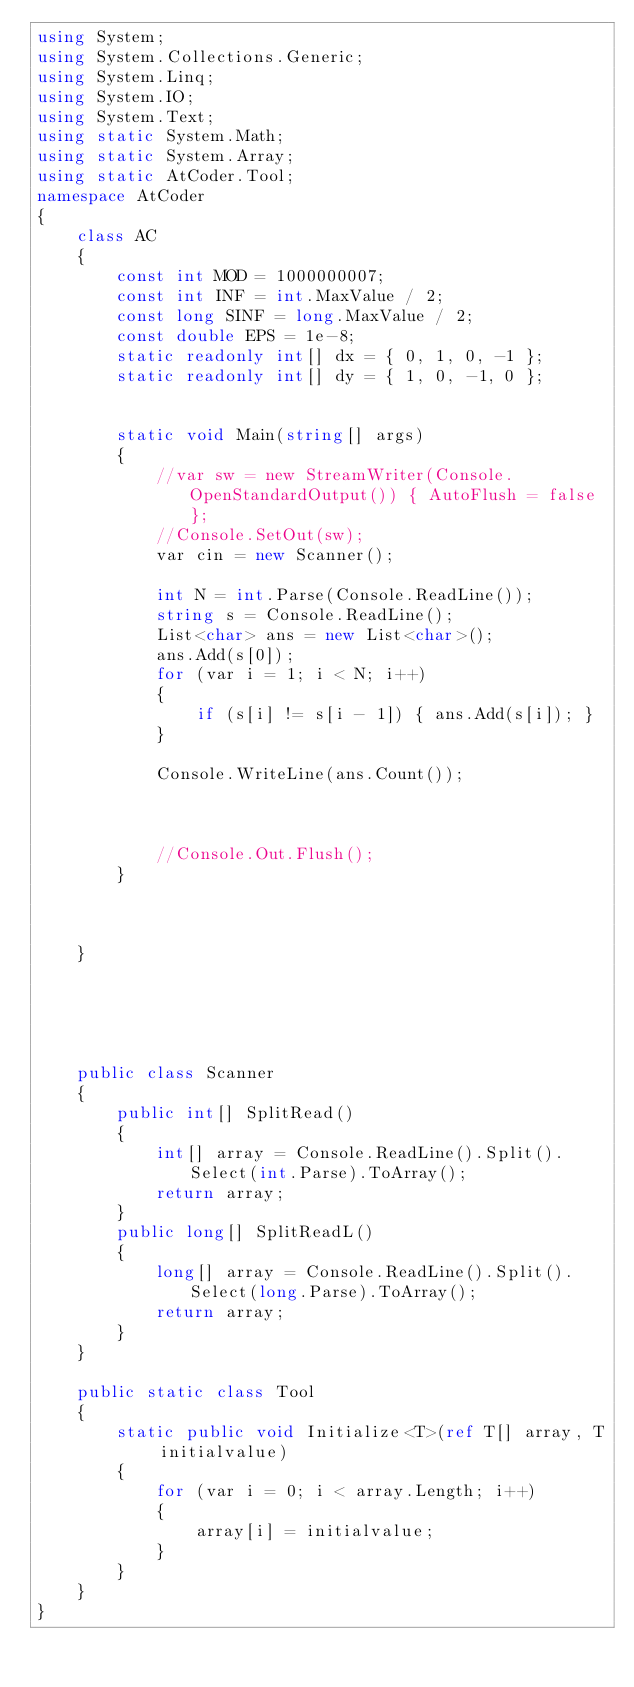Convert code to text. <code><loc_0><loc_0><loc_500><loc_500><_C#_>using System;
using System.Collections.Generic;
using System.Linq;
using System.IO;
using System.Text;
using static System.Math;
using static System.Array;
using static AtCoder.Tool;
namespace AtCoder
{
    class AC
    {
        const int MOD = 1000000007;
        const int INF = int.MaxValue / 2;
        const long SINF = long.MaxValue / 2;
        const double EPS = 1e-8;
        static readonly int[] dx = { 0, 1, 0, -1 };
        static readonly int[] dy = { 1, 0, -1, 0 };
       

        static void Main(string[] args)
        {
            //var sw = new StreamWriter(Console.OpenStandardOutput()) { AutoFlush = false };
            //Console.SetOut(sw);
            var cin = new Scanner();

            int N = int.Parse(Console.ReadLine());
            string s = Console.ReadLine();
            List<char> ans = new List<char>();
            ans.Add(s[0]);
            for (var i = 1; i < N; i++)
            {
                if (s[i] != s[i - 1]) { ans.Add(s[i]); }
            }

            Console.WriteLine(ans.Count());

            

            //Console.Out.Flush();
        }
        


    }

    

    

    public class Scanner
    {
        public int[] SplitRead()
        {
            int[] array = Console.ReadLine().Split().Select(int.Parse).ToArray();
            return array;
        }
        public long[] SplitReadL()
        {
            long[] array = Console.ReadLine().Split().Select(long.Parse).ToArray();
            return array;
        }
    }

    public static class Tool
    {
        static public void Initialize<T>(ref T[] array, T initialvalue)
        {
            for (var i = 0; i < array.Length; i++)
            {
                array[i] = initialvalue;
            }
        }
    }
}
</code> 